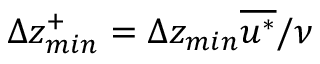<formula> <loc_0><loc_0><loc_500><loc_500>\Delta z _ { \min } ^ { + } = \Delta z _ { \min } \overline { { u ^ { * } } } / \nu</formula> 